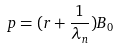<formula> <loc_0><loc_0><loc_500><loc_500>p = ( r + \frac { 1 } { \lambda _ { n } } ) B _ { 0 }</formula> 